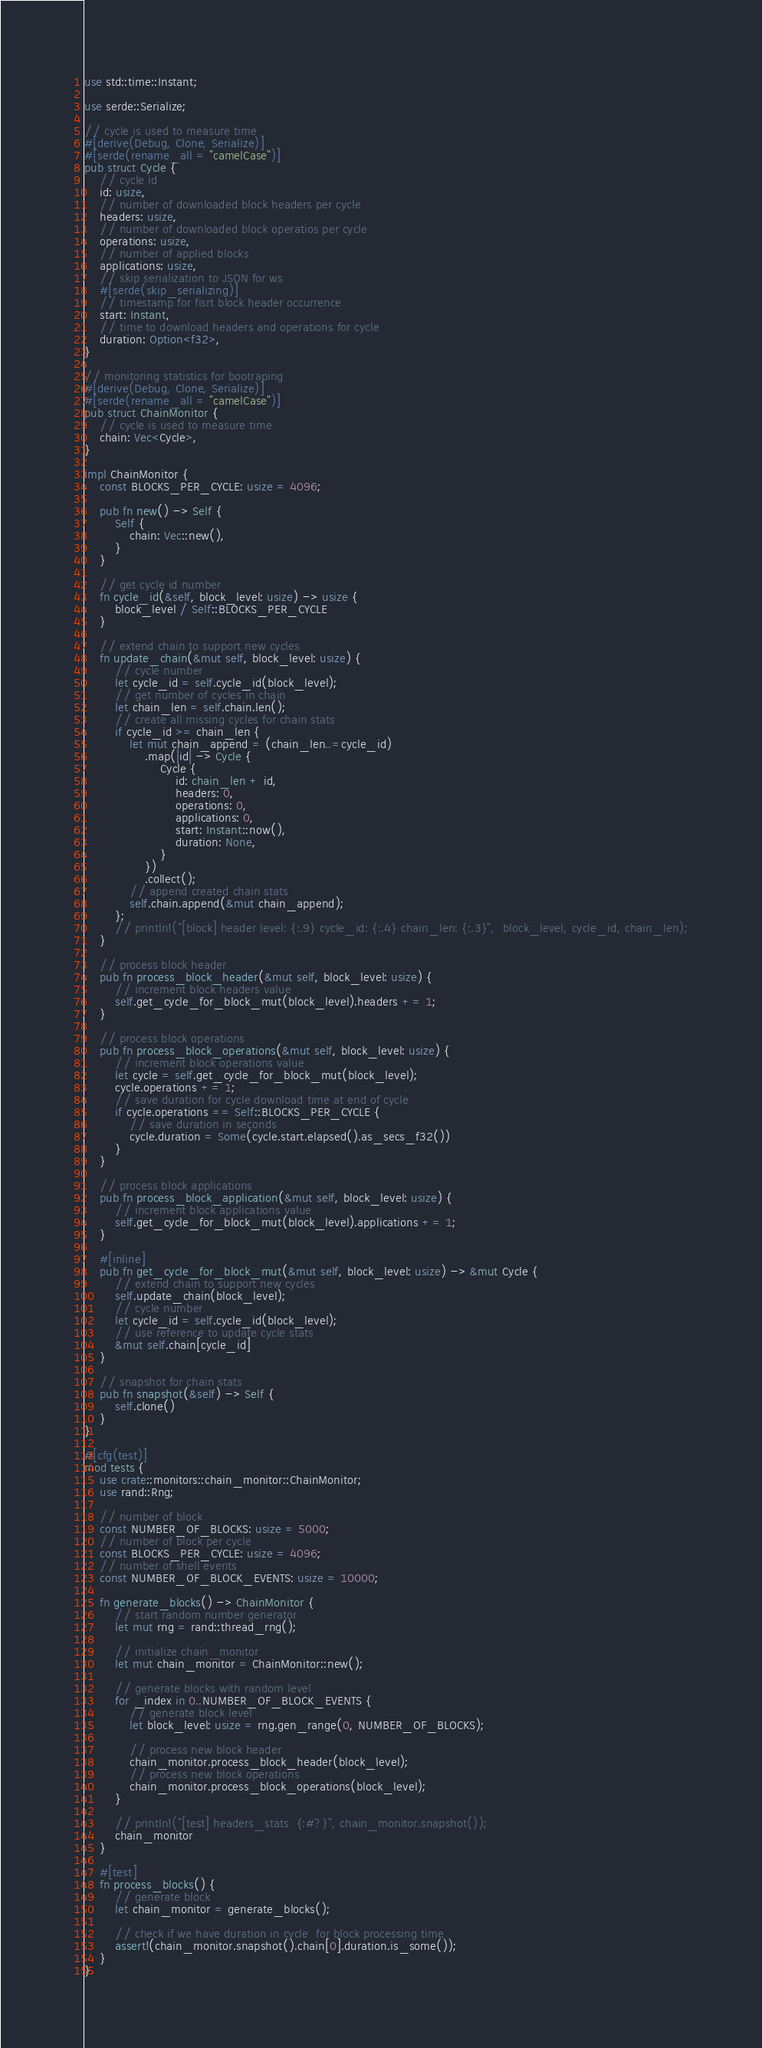<code> <loc_0><loc_0><loc_500><loc_500><_Rust_>use std::time::Instant;

use serde::Serialize;

// cycle is used to measure time
#[derive(Debug, Clone, Serialize)]
#[serde(rename_all = "camelCase")]
pub struct Cycle {
    // cycle id
    id: usize,
    // number of downloaded block headers per cycle
    headers: usize,
    // number of downloaded block operatios per cycle
    operations: usize,
    // number of applied blocks
    applications: usize,
    // skip serialization to JSON for ws
    #[serde(skip_serializing)]
    // timestamp for fisrt block header occurrence
    start: Instant,
    // time to download headers and operations for cycle
    duration: Option<f32>,
}

// monitoring statistics for bootraping
#[derive(Debug, Clone, Serialize)]
#[serde(rename_all = "camelCase")]
pub struct ChainMonitor {
    // cycle is used to measure time
    chain: Vec<Cycle>,
}

impl ChainMonitor {
    const BLOCKS_PER_CYCLE: usize = 4096;

    pub fn new() -> Self {
        Self {
            chain: Vec::new(),
        }
    }

    // get cycle id number
    fn cycle_id(&self, block_level: usize) -> usize {
        block_level / Self::BLOCKS_PER_CYCLE
    }

    // extend chain to support new cycles
    fn update_chain(&mut self, block_level: usize) {
        // cycle number
        let cycle_id = self.cycle_id(block_level);
        // get number of cycles in chain
        let chain_len = self.chain.len();
        // create all missing cycles for chain stats
        if cycle_id >= chain_len {
            let mut chain_append = (chain_len..=cycle_id)
                .map(|id| -> Cycle {
                    Cycle {
                        id: chain_len + id,
                        headers: 0,
                        operations: 0,
                        applications: 0,
                        start: Instant::now(),
                        duration: None,
                    }
                })
                .collect();
            // append created chain stats
            self.chain.append(&mut chain_append);
        };
        // println!("[block] header level: {:.9} cycle_id: {:.4} chain_len: {:.3}",  block_level, cycle_id, chain_len);
    }

    // process block header
    pub fn process_block_header(&mut self, block_level: usize) {
        // increment block headers value
        self.get_cycle_for_block_mut(block_level).headers += 1;
    }

    // process block operations
    pub fn process_block_operations(&mut self, block_level: usize) {
        // increment block operations value
        let cycle = self.get_cycle_for_block_mut(block_level);
        cycle.operations += 1;
        // save duration for cycle download time at end of cycle
        if cycle.operations == Self::BLOCKS_PER_CYCLE {
            // save duration in seconds
            cycle.duration = Some(cycle.start.elapsed().as_secs_f32())
        }
    }

    // process block applications
    pub fn process_block_application(&mut self, block_level: usize) {
        // increment block applications value
        self.get_cycle_for_block_mut(block_level).applications += 1;
    }

    #[inline]
    pub fn get_cycle_for_block_mut(&mut self, block_level: usize) -> &mut Cycle {
        // extend chain to support new cycles
        self.update_chain(block_level);
        // cycle number
        let cycle_id = self.cycle_id(block_level);
        // use reference to update cycle stats
        &mut self.chain[cycle_id]
    }

    // snapshot for chain stats
    pub fn snapshot(&self) -> Self {
        self.clone()
    }
}

#[cfg(test)]
mod tests {
    use crate::monitors::chain_monitor::ChainMonitor;
    use rand::Rng;

    // number of block
    const NUMBER_OF_BLOCKS: usize = 5000;
    // number of block per cycle
    const BLOCKS_PER_CYCLE: usize = 4096;
    // number of shell events
    const NUMBER_OF_BLOCK_EVENTS: usize = 10000;

    fn generate_blocks() -> ChainMonitor {
        // start random number generator
        let mut rng = rand::thread_rng();

        // initialize chain_monitor
        let mut chain_monitor = ChainMonitor::new();

        // generate blocks with random level 
        for _index in 0..NUMBER_OF_BLOCK_EVENTS {
            // generate block level
            let block_level: usize = rng.gen_range(0, NUMBER_OF_BLOCKS);

            // process new block header
            chain_monitor.process_block_header(block_level);
            // process new block operations
            chain_monitor.process_block_operations(block_level);
        }

        // println!("[test] headers_stats  {:#?}", chain_monitor.snapshot());
        chain_monitor
    }

    #[test]
    fn process_blocks() {
        // generate block
        let chain_monitor = generate_blocks();

        // check if we have duration in cycle  for block processing time 
        assert!(chain_monitor.snapshot().chain[0].duration.is_some());
    }
}
</code> 